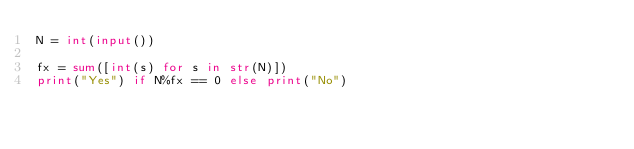<code> <loc_0><loc_0><loc_500><loc_500><_Python_>N = int(input())

fx = sum([int(s) for s in str(N)])
print("Yes") if N%fx == 0 else print("No")
</code> 